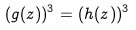Convert formula to latex. <formula><loc_0><loc_0><loc_500><loc_500>( g ( z ) ) ^ { 3 } = ( h ( z ) ) ^ { 3 }</formula> 